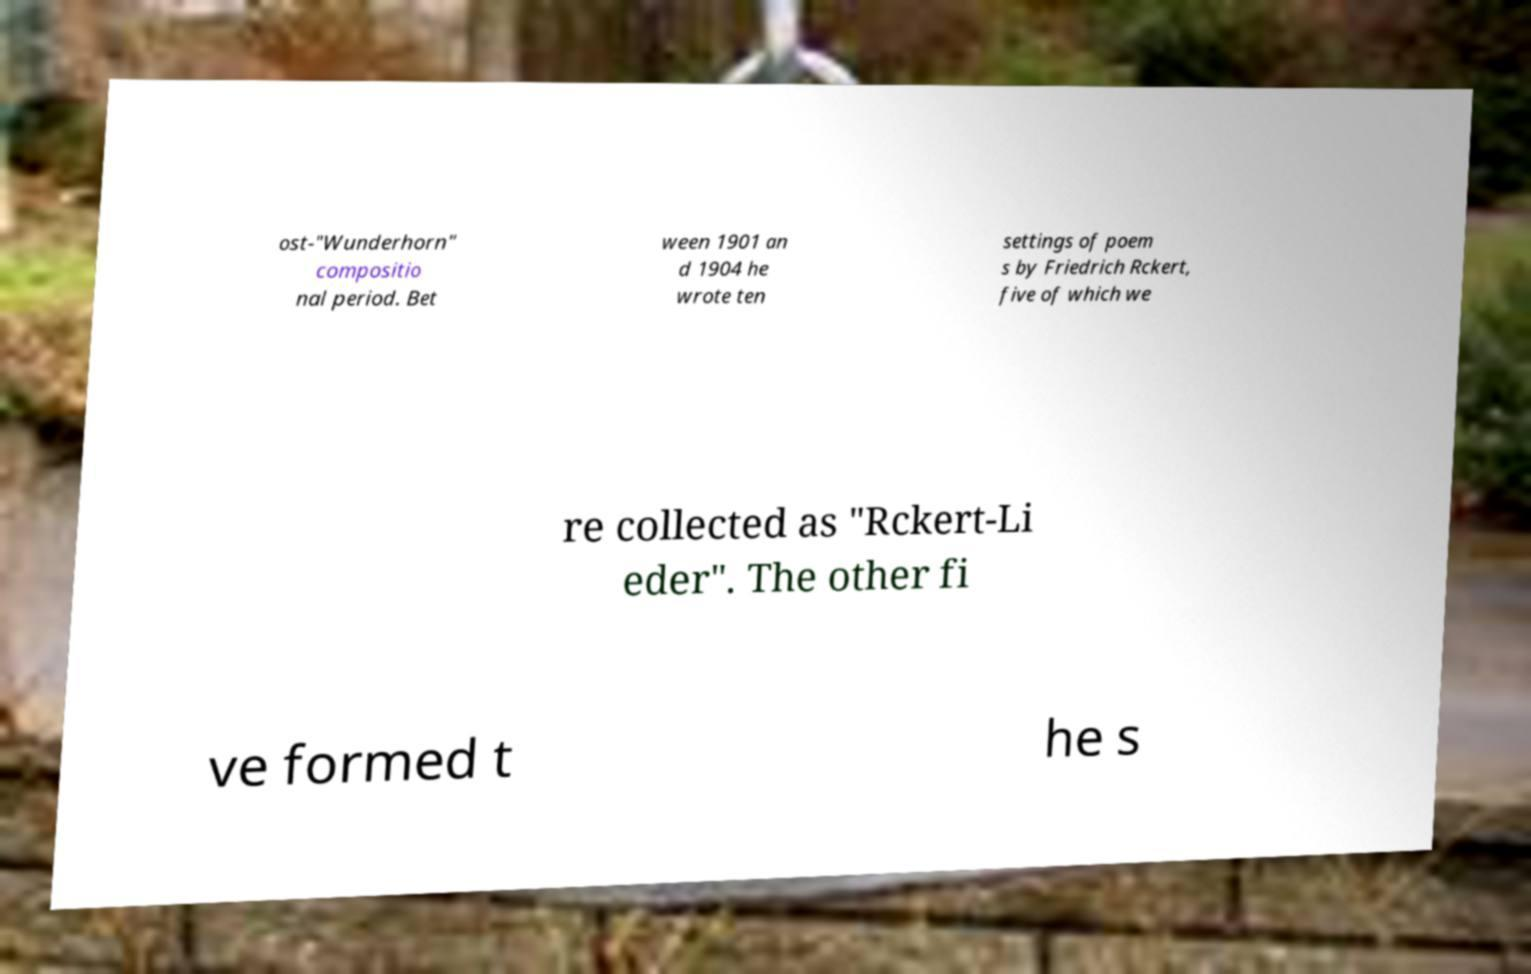What messages or text are displayed in this image? I need them in a readable, typed format. ost-"Wunderhorn" compositio nal period. Bet ween 1901 an d 1904 he wrote ten settings of poem s by Friedrich Rckert, five of which we re collected as "Rckert-Li eder". The other fi ve formed t he s 